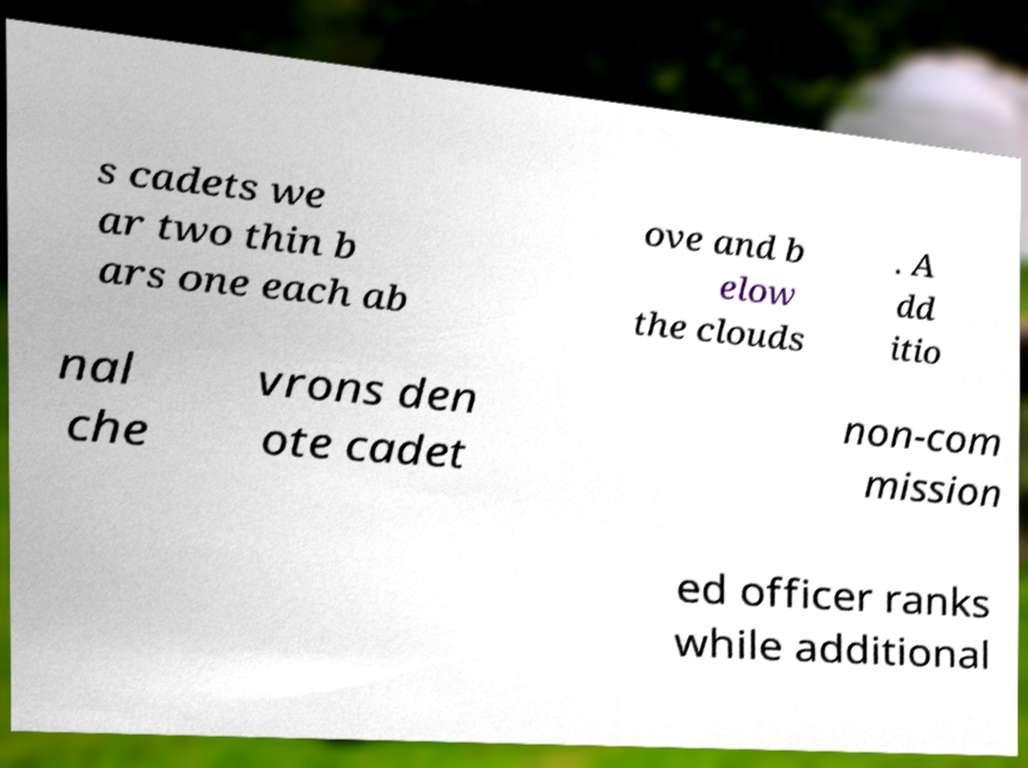Please identify and transcribe the text found in this image. s cadets we ar two thin b ars one each ab ove and b elow the clouds . A dd itio nal che vrons den ote cadet non-com mission ed officer ranks while additional 